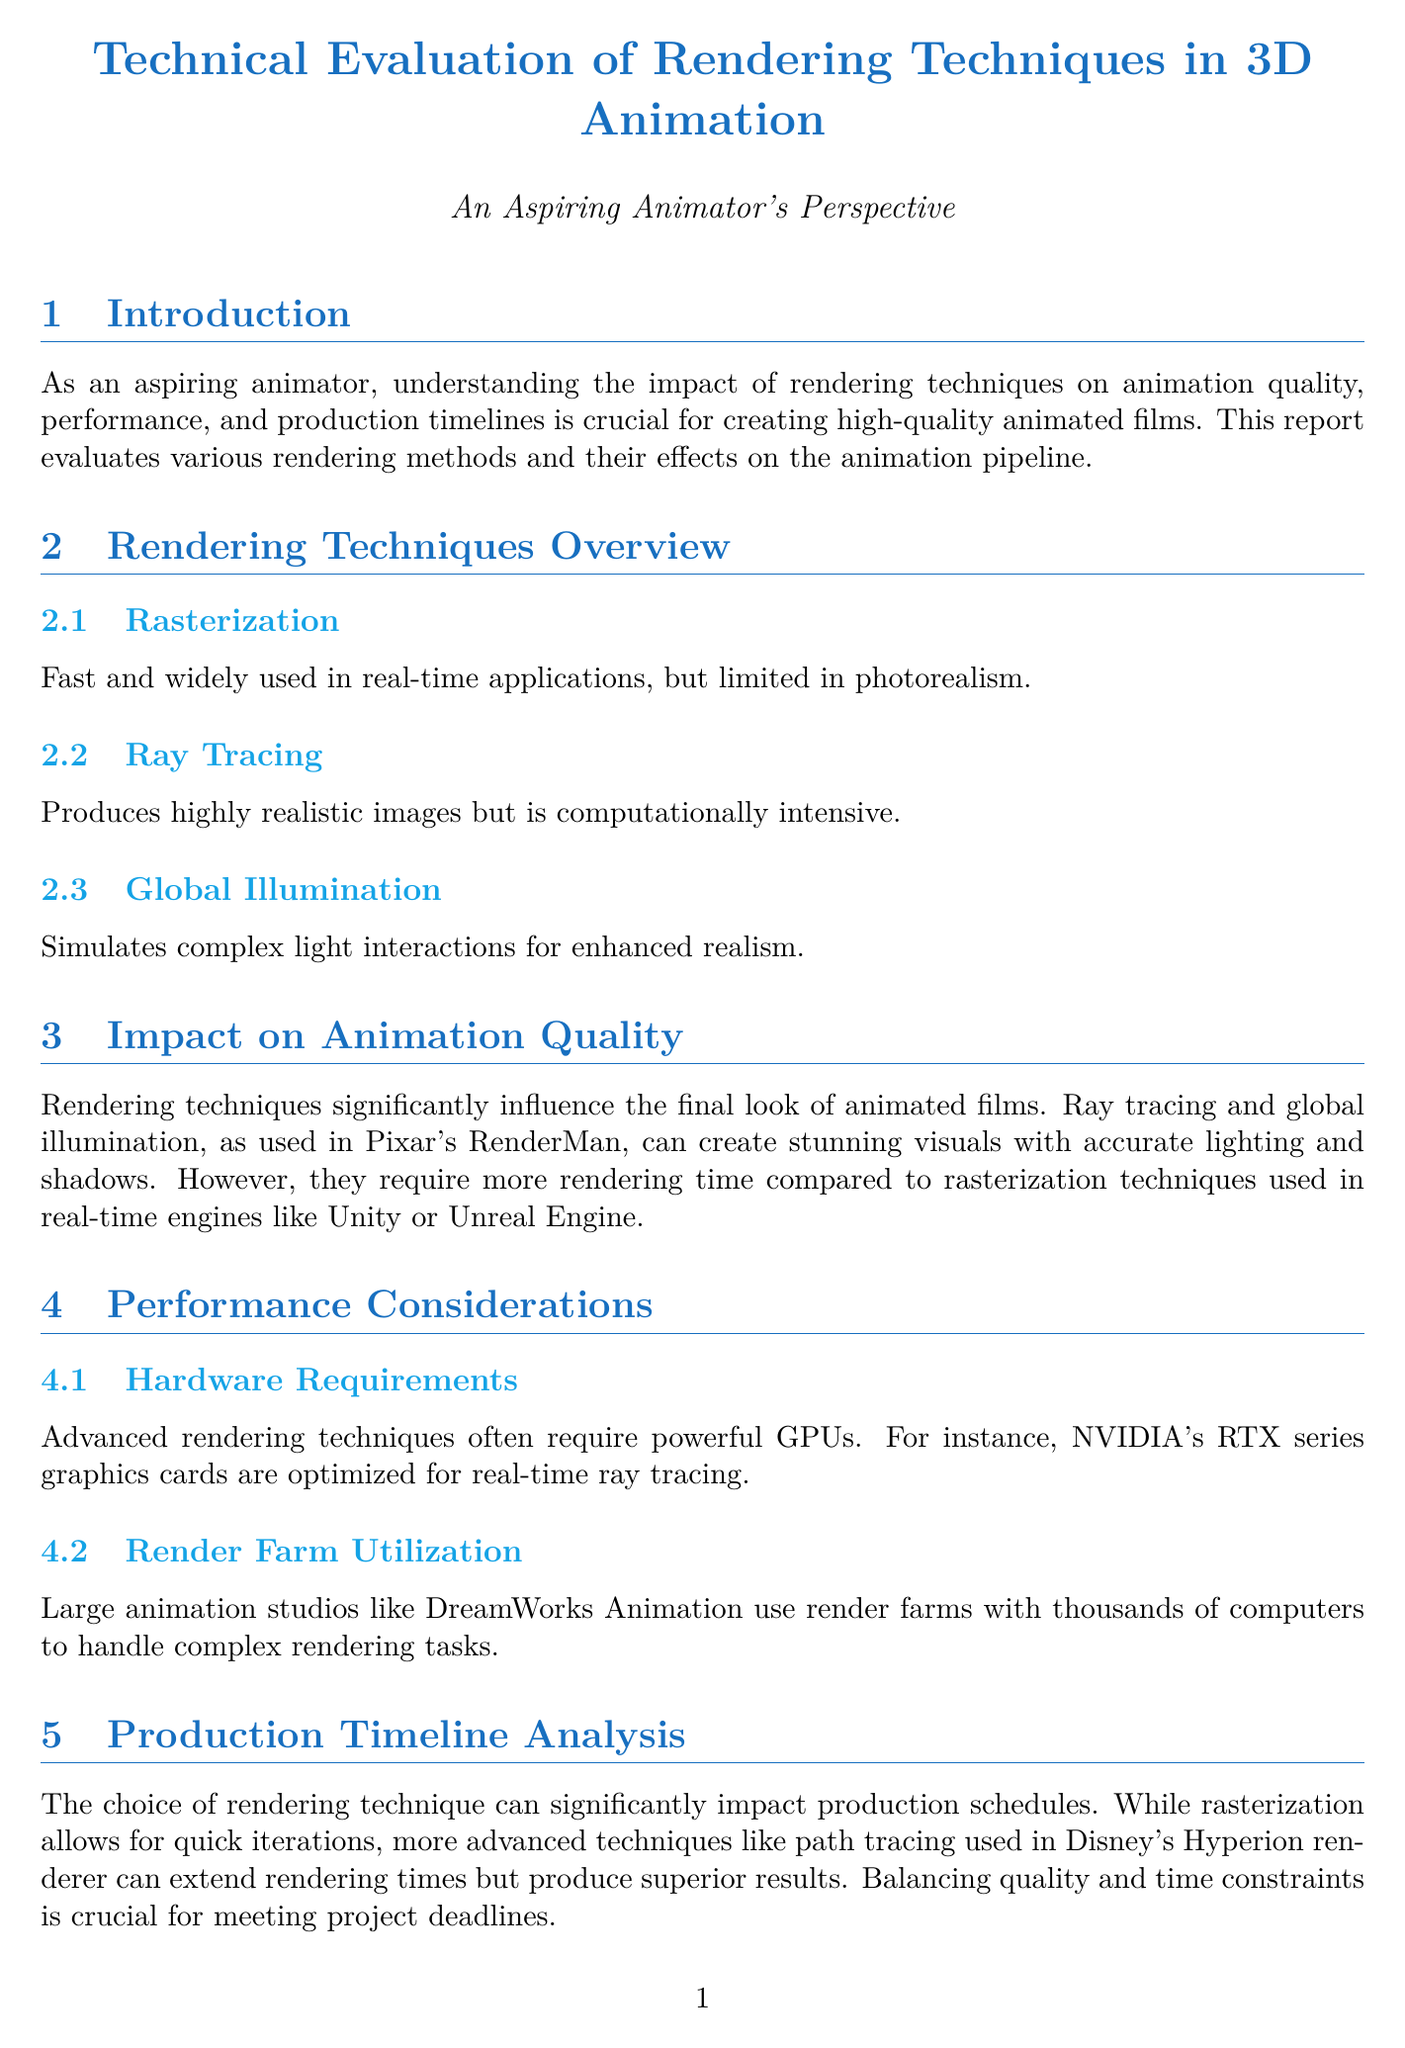What are the three rendering techniques discussed? The document lists Rasterization, Ray Tracing, and Global Illumination as the three rendering techniques.
Answer: Rasterization, Ray Tracing, Global Illumination Which rendering technique produces highly realistic images? The document mentions that Ray Tracing produces highly realistic images.
Answer: Ray Tracing What kind of hardware is optimized for real-time ray tracing? The document specifies that NVIDIA's RTX series graphics cards are optimized for real-time ray tracing.
Answer: NVIDIA's RTX series Which animation studio is mentioned as using render farms? The document states that DreamWorks Animation uses render farms for rendering tasks.
Answer: DreamWorks Animation What is the main trade-off discussed in relation to rendering techniques? The document highlights the trade-off between animation quality and production timelines.
Answer: Animation quality and production timelines Which two films are used as case studies? The document references Toy Story 4 and Spider-Man: Into the Spider-Verse as case studies.
Answer: Toy Story 4, Spider-Man: Into the Spider-Verse What emerging technology is mentioned that can reduce render times? The document specifies AI-assisted rendering, such as NVIDIA's DLSS technology, as an emerging technology that can reduce render times.
Answer: NVIDIA's DLSS technology What is the conclusion's focus for aspiring animators? The conclusion emphasizes understanding the trade-offs between different rendering techniques.
Answer: Understanding the trade-offs between different rendering techniques 